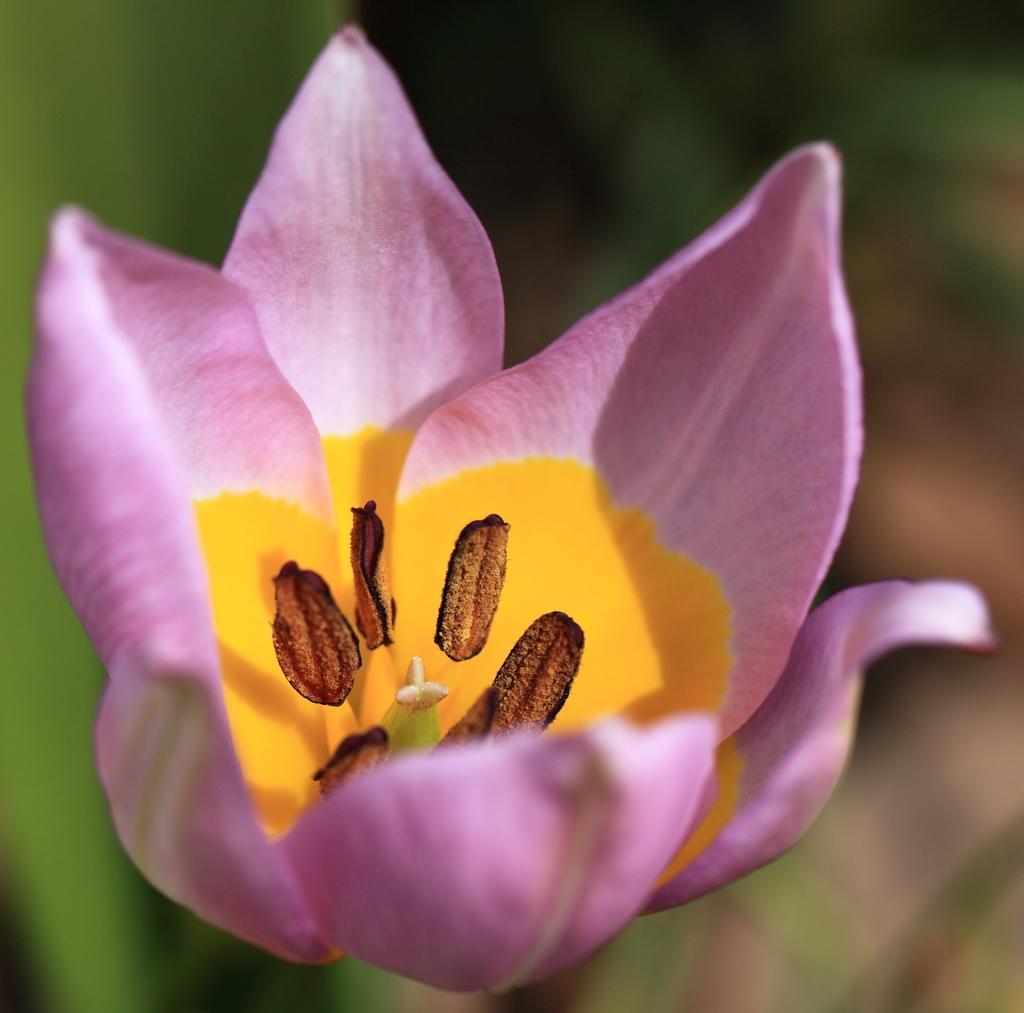In one or two sentences, can you explain what this image depicts? In the picture I can see pink color flower where I can see it's stamen. The background of the image is blurred which is in green color. 